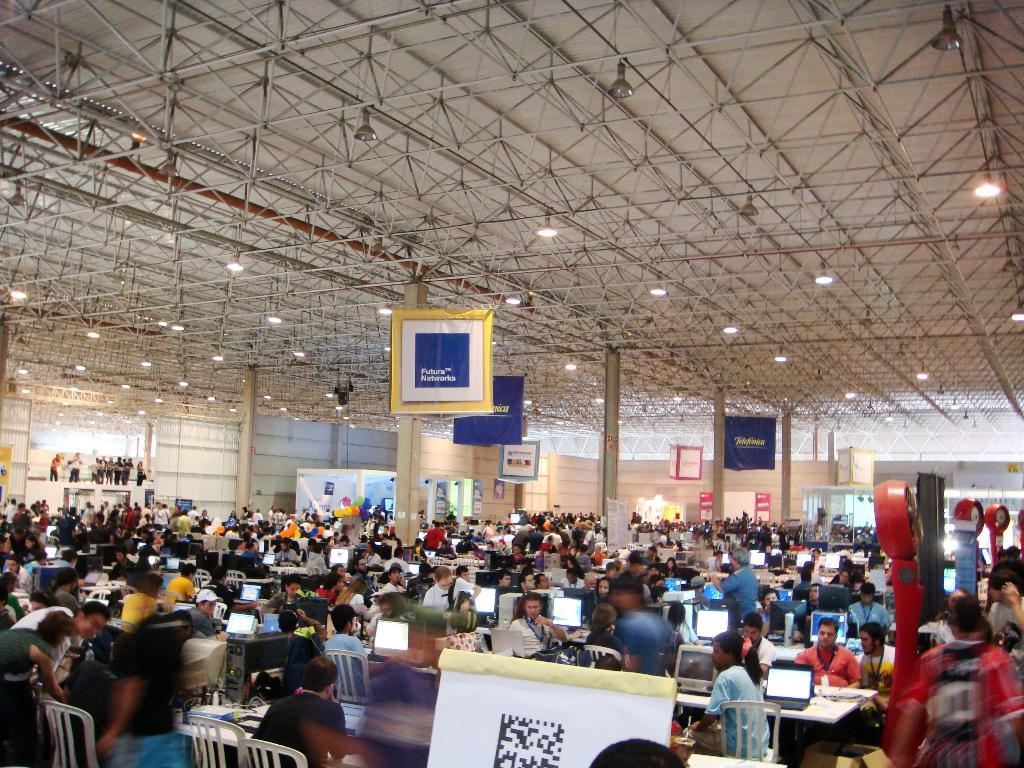What are the people in the image doing? The people in the image are sitting and standing. What objects are present for the people to sit on? There are chairs in the image for the people to sit on. What electronic devices can be seen in the image? There are laptops in the image. What type of signage is present in the image? There are hanging boards with text in the image. What is the structure above the people and chairs? The image includes a roof with lights. What type of flower is growing on the knee of the person sitting in the image? There are no flowers present in the image, and no one's knee is visible. 